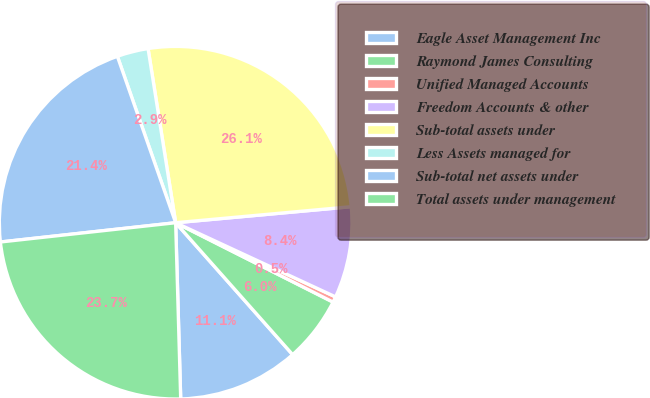<chart> <loc_0><loc_0><loc_500><loc_500><pie_chart><fcel>Eagle Asset Management Inc<fcel>Raymond James Consulting<fcel>Unified Managed Accounts<fcel>Freedom Accounts & other<fcel>Sub-total assets under<fcel>Less Assets managed for<fcel>Sub-total net assets under<fcel>Total assets under management<nl><fcel>11.09%<fcel>6.02%<fcel>0.52%<fcel>8.36%<fcel>26.05%<fcel>2.86%<fcel>21.38%<fcel>23.71%<nl></chart> 